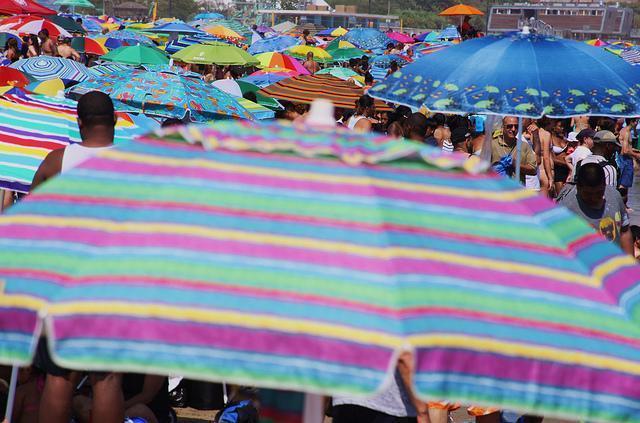How many umbrellas are there?
Give a very brief answer. 5. How many people are there?
Give a very brief answer. 2. 